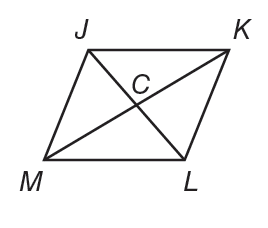Answer the mathemtical geometry problem and directly provide the correct option letter.
Question: J K L M is a rhombus. If C K = 8 and J K = 10. Find J C.
Choices: A: 4 B: 6 C: 8 D: 10 B 